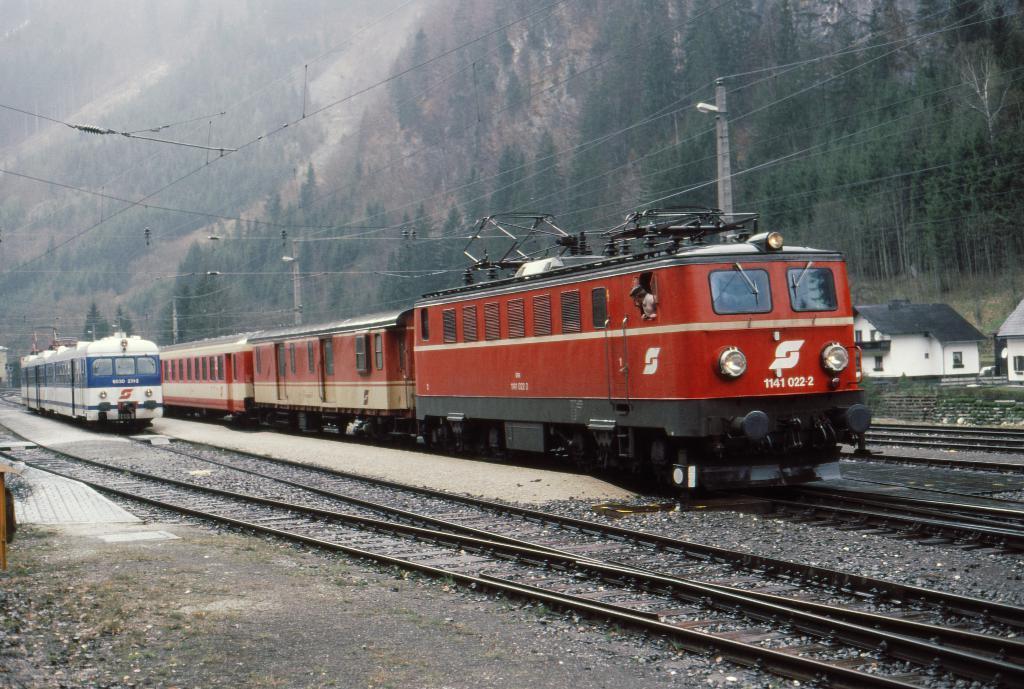How would you summarize this image in a sentence or two? In this picture I can observe two trains moving on the railway tracks. They are in red, blue and white colors. On the right side I can observe houses. In the background there is a hill and I can observe some trees. 